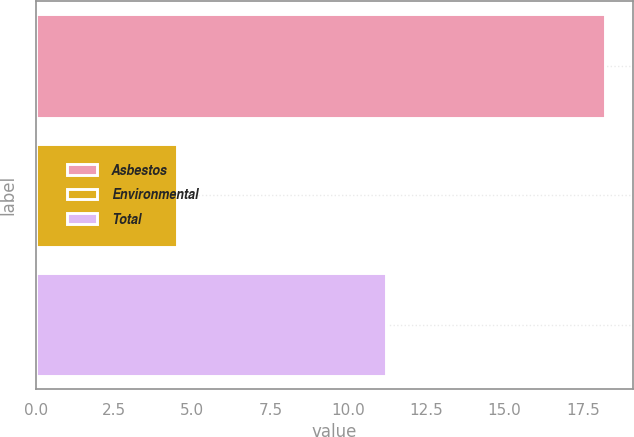Convert chart to OTSL. <chart><loc_0><loc_0><loc_500><loc_500><bar_chart><fcel>Asbestos<fcel>Environmental<fcel>Total<nl><fcel>18.2<fcel>4.5<fcel>11.2<nl></chart> 